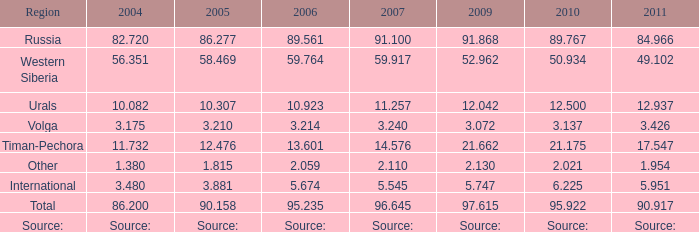100 million tonnes? 86.277. 